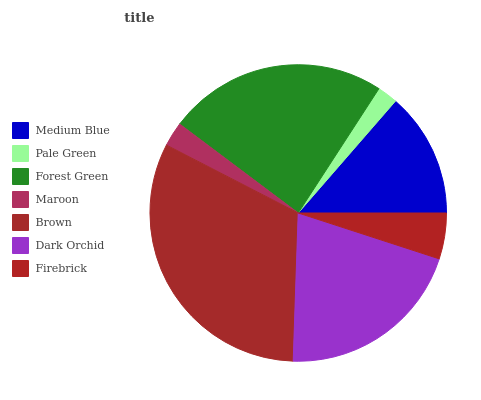Is Pale Green the minimum?
Answer yes or no. Yes. Is Brown the maximum?
Answer yes or no. Yes. Is Forest Green the minimum?
Answer yes or no. No. Is Forest Green the maximum?
Answer yes or no. No. Is Forest Green greater than Pale Green?
Answer yes or no. Yes. Is Pale Green less than Forest Green?
Answer yes or no. Yes. Is Pale Green greater than Forest Green?
Answer yes or no. No. Is Forest Green less than Pale Green?
Answer yes or no. No. Is Medium Blue the high median?
Answer yes or no. Yes. Is Medium Blue the low median?
Answer yes or no. Yes. Is Forest Green the high median?
Answer yes or no. No. Is Brown the low median?
Answer yes or no. No. 